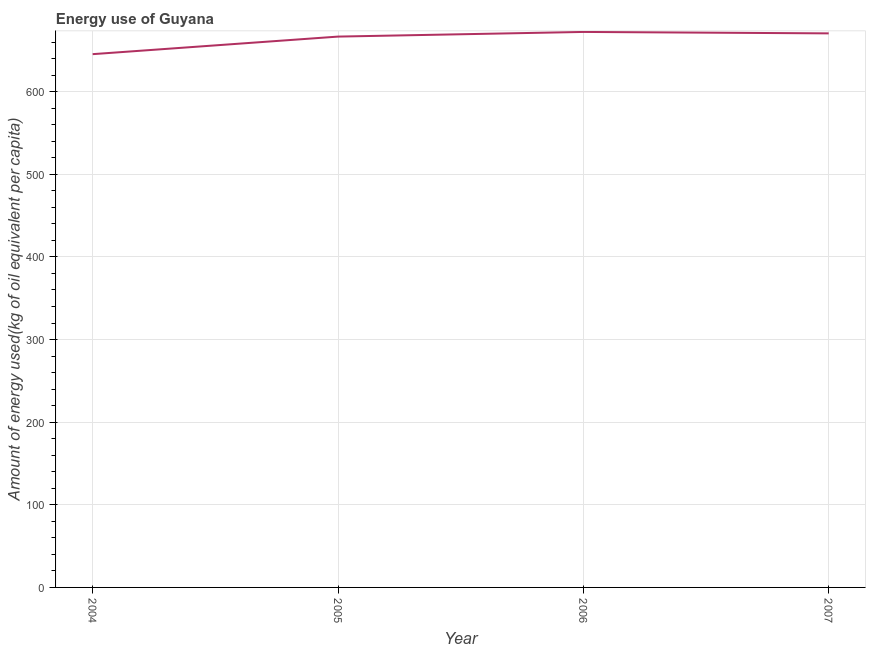What is the amount of energy used in 2005?
Your answer should be compact. 666.67. Across all years, what is the maximum amount of energy used?
Provide a short and direct response. 672.31. Across all years, what is the minimum amount of energy used?
Your response must be concise. 645.41. In which year was the amount of energy used minimum?
Make the answer very short. 2004. What is the sum of the amount of energy used?
Provide a short and direct response. 2654.96. What is the difference between the amount of energy used in 2004 and 2007?
Your answer should be compact. -25.16. What is the average amount of energy used per year?
Keep it short and to the point. 663.74. What is the median amount of energy used?
Ensure brevity in your answer.  668.62. In how many years, is the amount of energy used greater than 360 kg?
Provide a short and direct response. 4. What is the ratio of the amount of energy used in 2005 to that in 2007?
Make the answer very short. 0.99. Is the difference between the amount of energy used in 2004 and 2005 greater than the difference between any two years?
Give a very brief answer. No. What is the difference between the highest and the second highest amount of energy used?
Your response must be concise. 1.74. What is the difference between the highest and the lowest amount of energy used?
Your answer should be compact. 26.9. In how many years, is the amount of energy used greater than the average amount of energy used taken over all years?
Give a very brief answer. 3. How many lines are there?
Your answer should be very brief. 1. How many years are there in the graph?
Offer a very short reply. 4. What is the difference between two consecutive major ticks on the Y-axis?
Your response must be concise. 100. Does the graph contain any zero values?
Make the answer very short. No. What is the title of the graph?
Your response must be concise. Energy use of Guyana. What is the label or title of the Y-axis?
Give a very brief answer. Amount of energy used(kg of oil equivalent per capita). What is the Amount of energy used(kg of oil equivalent per capita) in 2004?
Your response must be concise. 645.41. What is the Amount of energy used(kg of oil equivalent per capita) of 2005?
Provide a succinct answer. 666.67. What is the Amount of energy used(kg of oil equivalent per capita) of 2006?
Provide a short and direct response. 672.31. What is the Amount of energy used(kg of oil equivalent per capita) in 2007?
Your answer should be compact. 670.57. What is the difference between the Amount of energy used(kg of oil equivalent per capita) in 2004 and 2005?
Keep it short and to the point. -21.26. What is the difference between the Amount of energy used(kg of oil equivalent per capita) in 2004 and 2006?
Offer a terse response. -26.9. What is the difference between the Amount of energy used(kg of oil equivalent per capita) in 2004 and 2007?
Provide a succinct answer. -25.16. What is the difference between the Amount of energy used(kg of oil equivalent per capita) in 2005 and 2006?
Offer a very short reply. -5.64. What is the difference between the Amount of energy used(kg of oil equivalent per capita) in 2005 and 2007?
Your response must be concise. -3.9. What is the difference between the Amount of energy used(kg of oil equivalent per capita) in 2006 and 2007?
Provide a short and direct response. 1.74. What is the ratio of the Amount of energy used(kg of oil equivalent per capita) in 2004 to that in 2005?
Give a very brief answer. 0.97. What is the ratio of the Amount of energy used(kg of oil equivalent per capita) in 2004 to that in 2007?
Make the answer very short. 0.96. What is the ratio of the Amount of energy used(kg of oil equivalent per capita) in 2005 to that in 2006?
Give a very brief answer. 0.99. What is the ratio of the Amount of energy used(kg of oil equivalent per capita) in 2005 to that in 2007?
Provide a succinct answer. 0.99. 